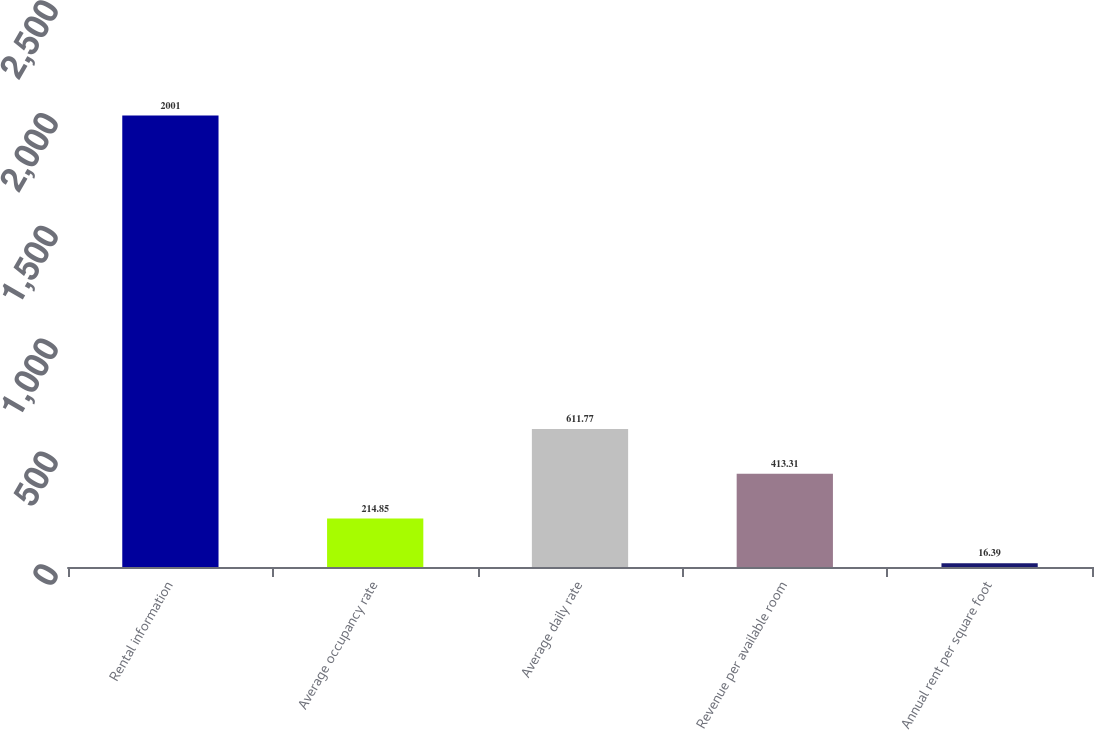<chart> <loc_0><loc_0><loc_500><loc_500><bar_chart><fcel>Rental information<fcel>Average occupancy rate<fcel>Average daily rate<fcel>Revenue per available room<fcel>Annual rent per square foot<nl><fcel>2001<fcel>214.85<fcel>611.77<fcel>413.31<fcel>16.39<nl></chart> 